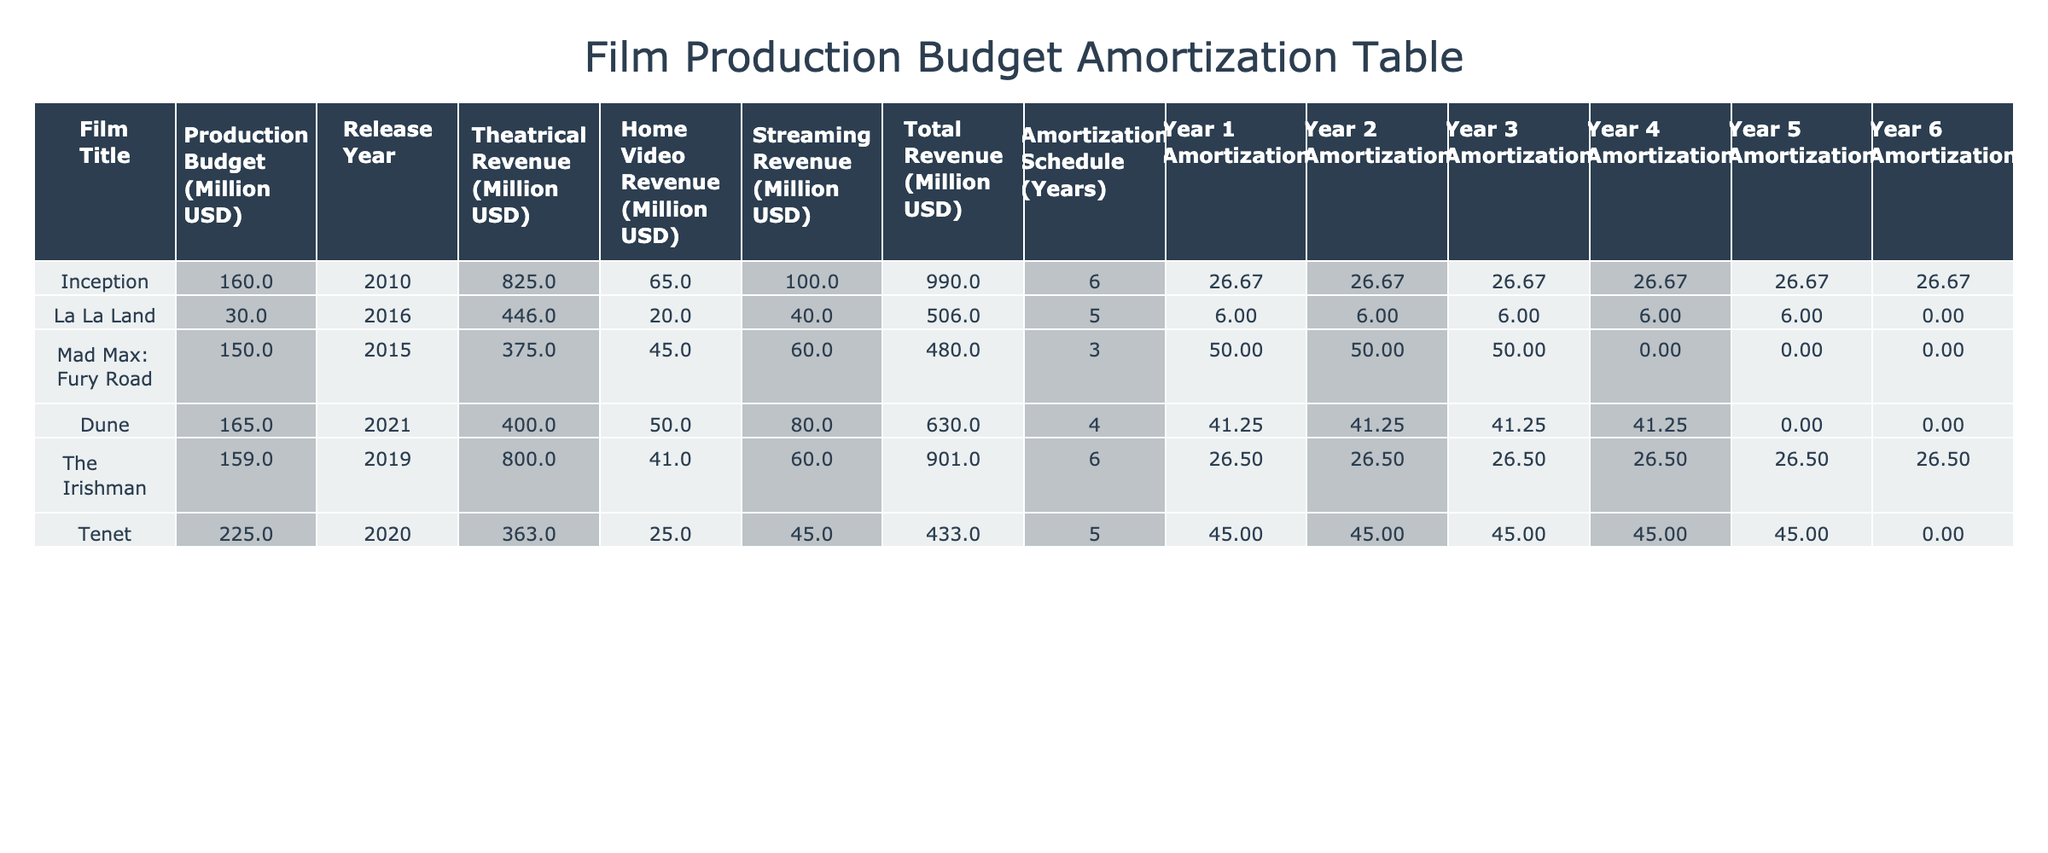What is the production budget for "Dune"? The production budget is explicitly listed in the table for "Dune", which states 165 million USD.
Answer: 165 million USD How much revenue did "The Irishman" generate from theatrical releases? The table shows that "The Irishman" generated 800 million USD from theatrical releases.
Answer: 800 million USD Which film had the highest total revenue, and how much was it? By comparing the total revenue column, "Inception" has the highest total revenue at 990 million USD, which can be confirmed by checking the respective row.
Answer: Inception, 990 million USD What is the average production budget of the films listed? The production budgets are 160, 30, 150, 165, 159, and 225 million USD. Summing these values gives 889 million USD, and dividing by 6 films yields 148.17 million USD.
Answer: 148.17 million USD Is the total revenue of "Tenet" greater than its production budget? "Tenet" has a production budget of 225 million USD and total revenue of 433 million USD; since 433 is greater than 225, the statement is true.
Answer: Yes What is the amortization period for "Mad Max: Fury Road"? The table directly indicates that "Mad Max: Fury Road" has an amortization schedule of 3 years.
Answer: 3 years Which film had the lowest home video revenue, and what was the amount? By comparing the home video revenue values, "The Irishman" shows the lowest at 41 million USD.
Answer: The Irishman, 41 million USD What is the total revenue from "La La Land" and "Mad Max: Fury Road" combined? The total revenue for "La La Land" is 506 million USD and for "Mad Max: Fury Road" it is 480 million USD. Adding these together gives 986 million USD.
Answer: 986 million USD Which films had an amortization schedule of 5 years, and what were their production budgets? The films with a 5-year amortization schedule are "La La Land" with a production budget of 30 million USD and "Tenet" with a 225 million USD budget.
Answer: La La Land, 30 million USD; Tenet, 225 million USD 